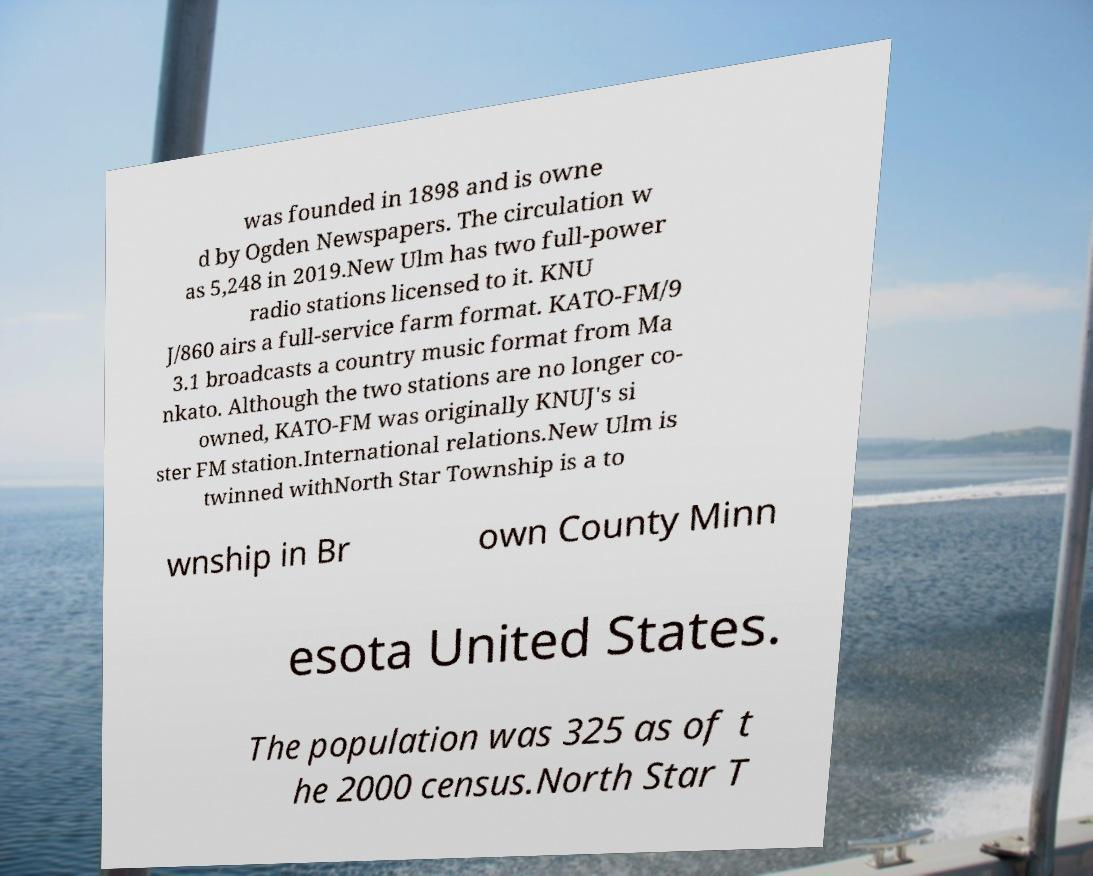Please read and relay the text visible in this image. What does it say? was founded in 1898 and is owne d by Ogden Newspapers. The circulation w as 5,248 in 2019.New Ulm has two full-power radio stations licensed to it. KNU J/860 airs a full-service farm format. KATO-FM/9 3.1 broadcasts a country music format from Ma nkato. Although the two stations are no longer co- owned, KATO-FM was originally KNUJ's si ster FM station.International relations.New Ulm is twinned withNorth Star Township is a to wnship in Br own County Minn esota United States. The population was 325 as of t he 2000 census.North Star T 